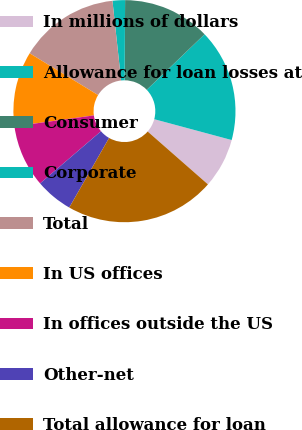<chart> <loc_0><loc_0><loc_500><loc_500><pie_chart><fcel>In millions of dollars<fcel>Allowance for loan losses at<fcel>Consumer<fcel>Corporate<fcel>Total<fcel>In US offices<fcel>In offices outside the US<fcel>Other-net<fcel>Total allowance for loan<nl><fcel>7.27%<fcel>16.36%<fcel>12.73%<fcel>1.82%<fcel>14.55%<fcel>10.91%<fcel>9.09%<fcel>5.45%<fcel>21.82%<nl></chart> 